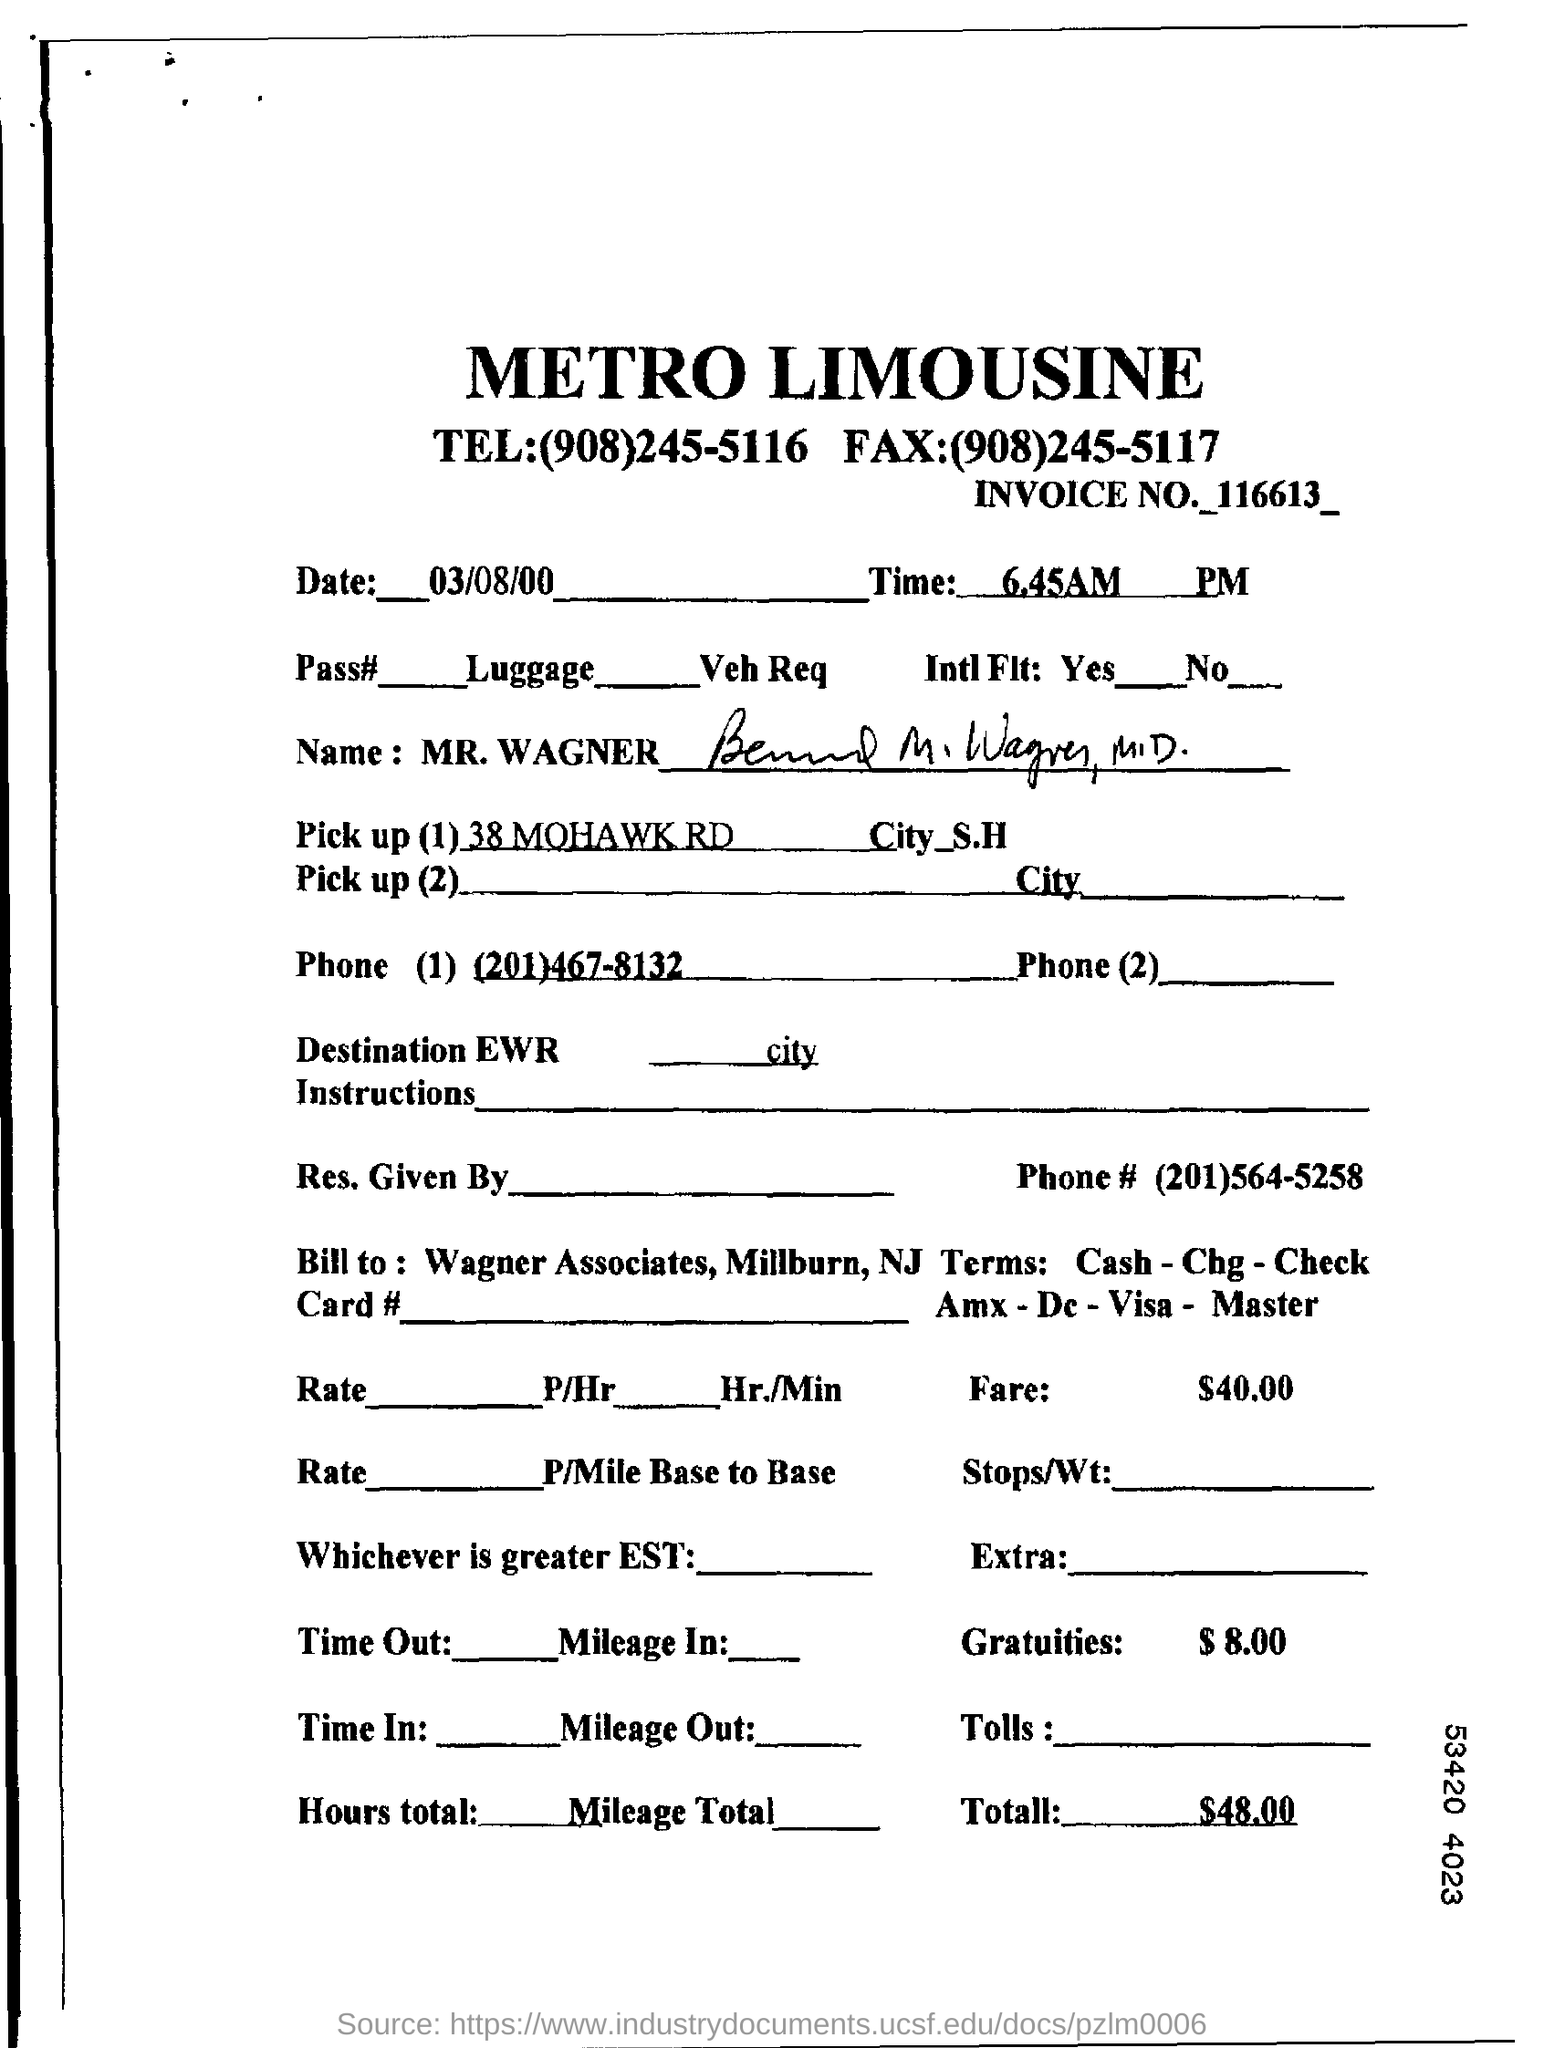What is the date mentioned in this document?
Provide a short and direct response. 03/08/00. What is the time mentioned in this document?
Your response must be concise. 6.45AM. What is the Invoice No given in this document?
Give a very brief answer. 116613. What is the total cost as per the document?
Your answer should be very brief. $48.00. 